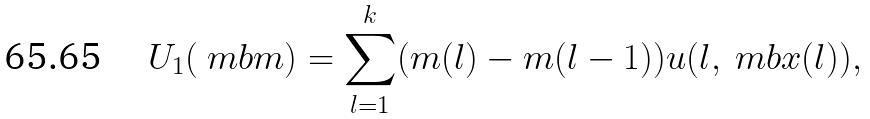Convert formula to latex. <formula><loc_0><loc_0><loc_500><loc_500>U _ { 1 } ( \ m b m ) = \sum _ { l = 1 } ^ { k } ( m ( l ) - m ( l - 1 ) ) u ( l , \ m b x ( l ) ) ,</formula> 